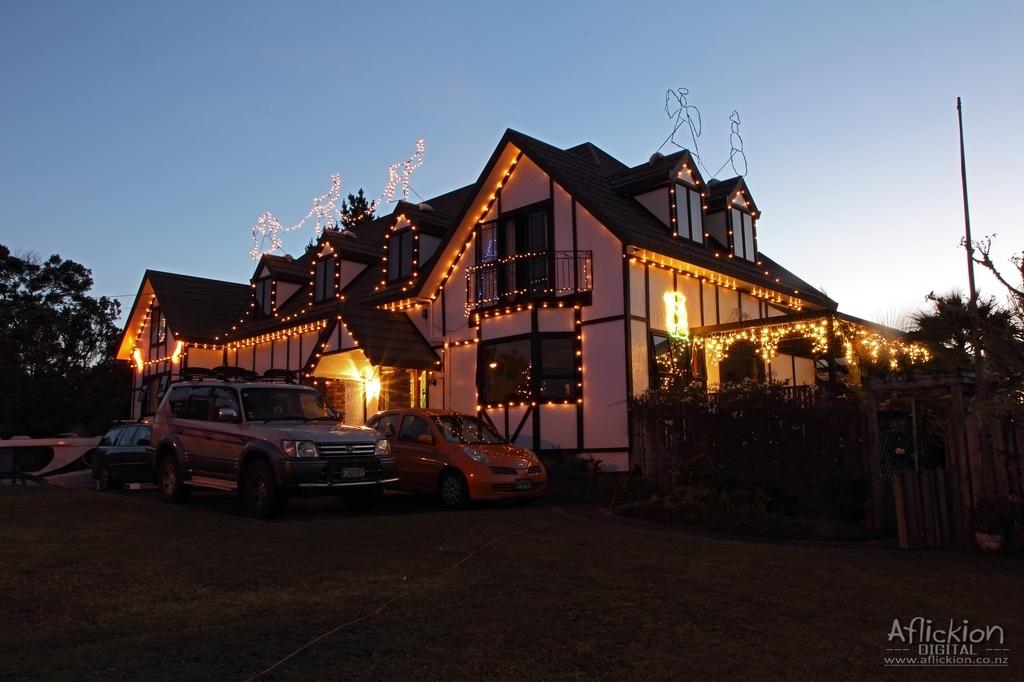What can be seen on the ground in the image? There are cars parked on the ground in the image. What structure is visible in the image? There is a building in the image. How is the building decorated? The building is decorated with lights. What type of vegetation is present in the image? There are trees in the image. What is the condition of the sky in the image? The sky is clear in the image. How many babies are crawling on the cars in the image? There are no babies present in the image; it features cars parked on the ground and a decorated building. What type of crook is holding a pail in the image? There is no crook or pail present in the image. 